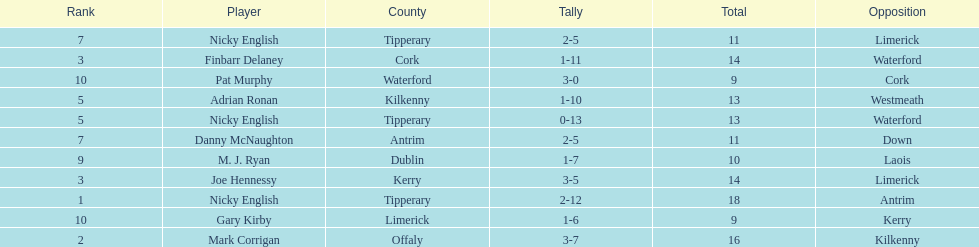What is the total number of points scored by joe hennessy and finbarr delaney? 14. 